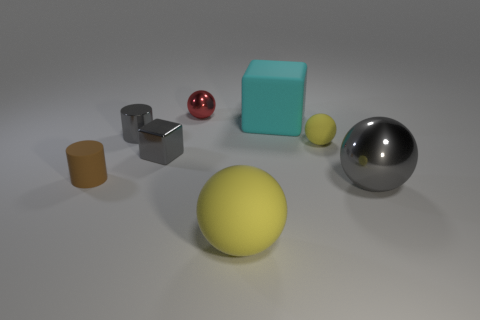Is there a big cyan object that has the same material as the brown cylinder?
Ensure brevity in your answer.  Yes. What is the shape of the rubber object that is to the right of the large rubber thing that is behind the yellow sphere right of the large cyan object?
Keep it short and to the point. Sphere. Does the gray shiny sphere have the same size as the rubber sphere that is in front of the big gray ball?
Give a very brief answer. Yes. The small thing that is both behind the tiny yellow object and to the right of the gray metal cube has what shape?
Offer a very short reply. Sphere. What number of tiny objects are either gray things or gray spheres?
Offer a terse response. 2. Is the number of big yellow rubber spheres that are right of the small gray cube the same as the number of cubes that are right of the gray sphere?
Give a very brief answer. No. How many other things are the same color as the metal cube?
Your answer should be very brief. 2. Are there an equal number of big gray metal spheres behind the large cube and big purple balls?
Your answer should be very brief. Yes. Is the size of the cyan matte object the same as the gray sphere?
Keep it short and to the point. Yes. There is a big object that is in front of the large cyan matte block and behind the large yellow rubber ball; what material is it?
Offer a very short reply. Metal. 